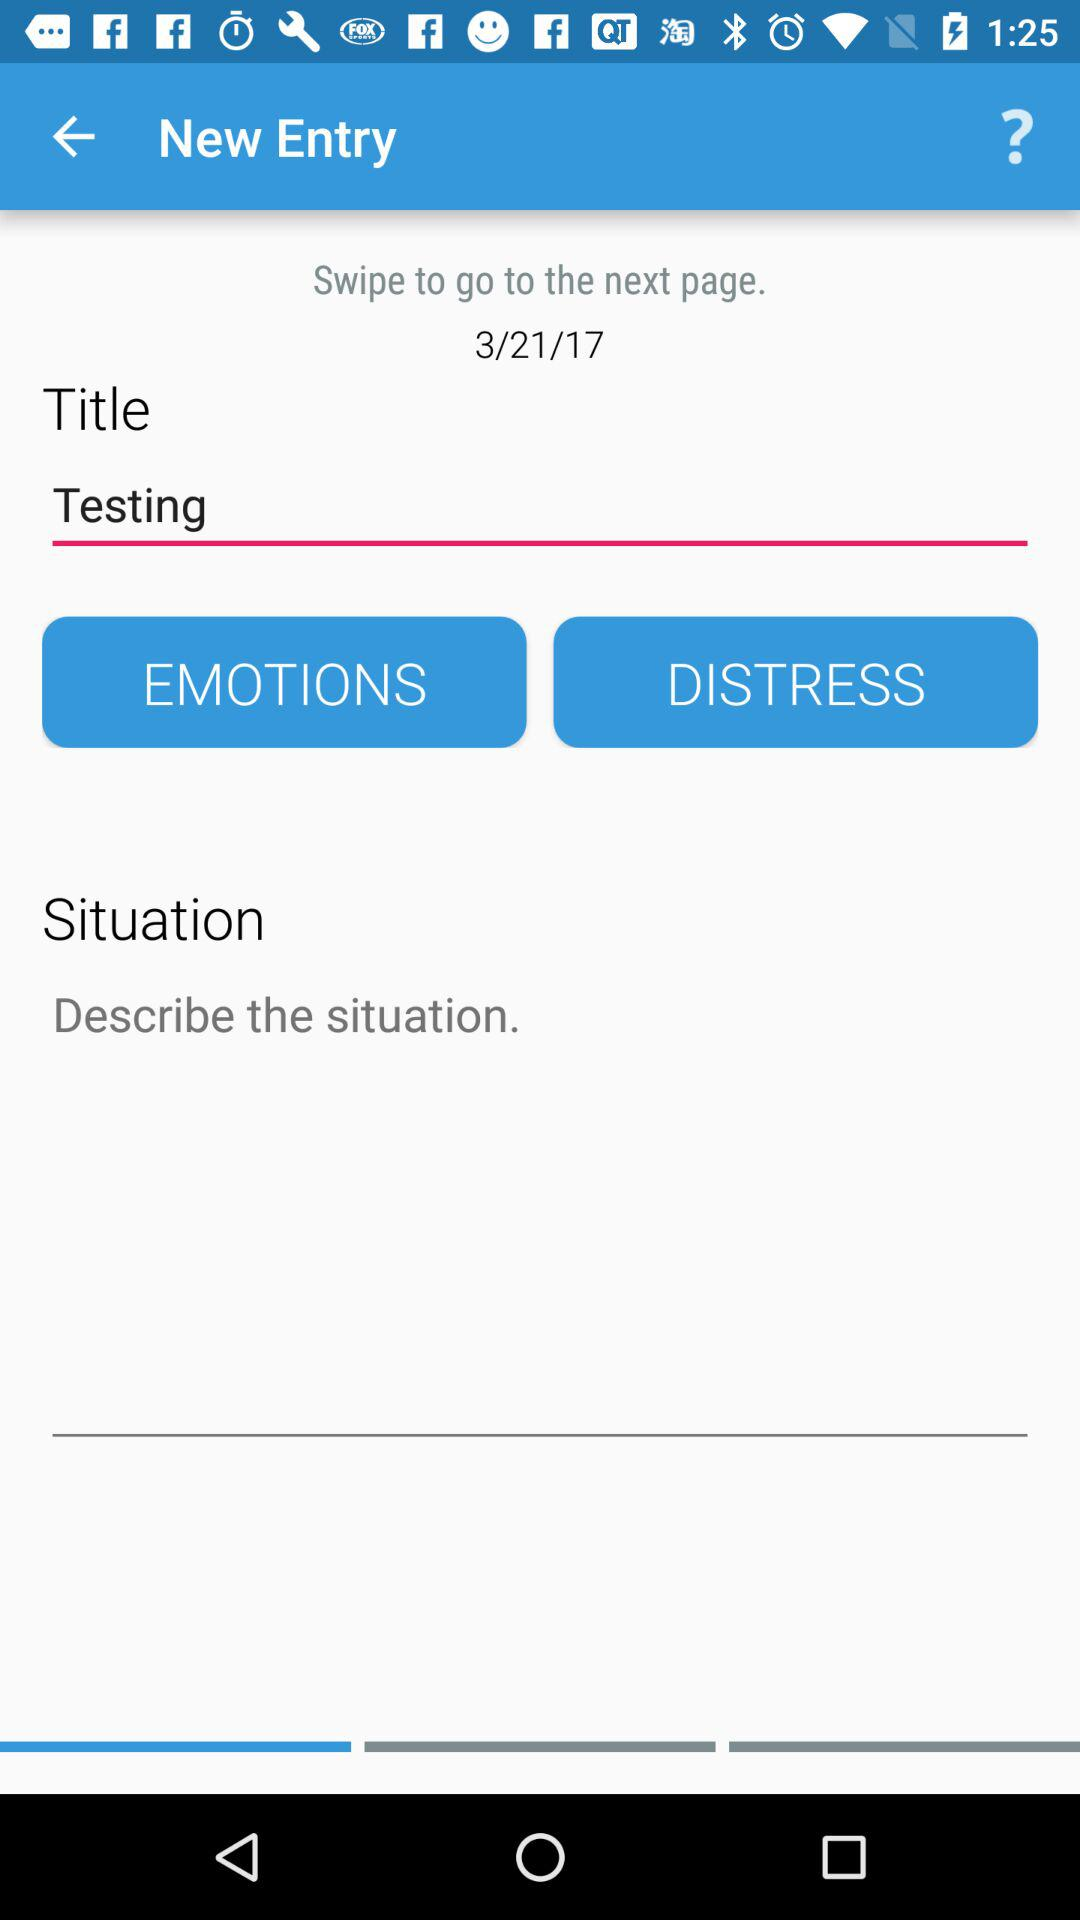On what date was the new entry created? The new entry was created on March 21, 2017. 